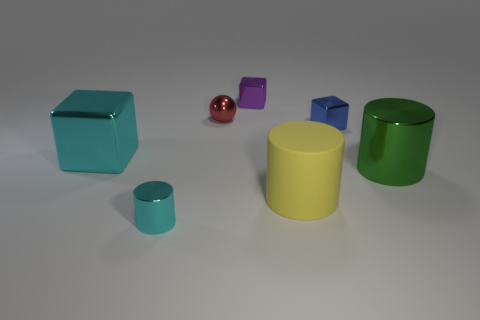Could you describe the setting in which these objects are placed? The objects are arranged on a flat surface with a neutral background. The shadows and lighting suggest an indoor setting with a light source coming from the top left, possibly within a studio environment for creating a 3D render or a photographic still life. 